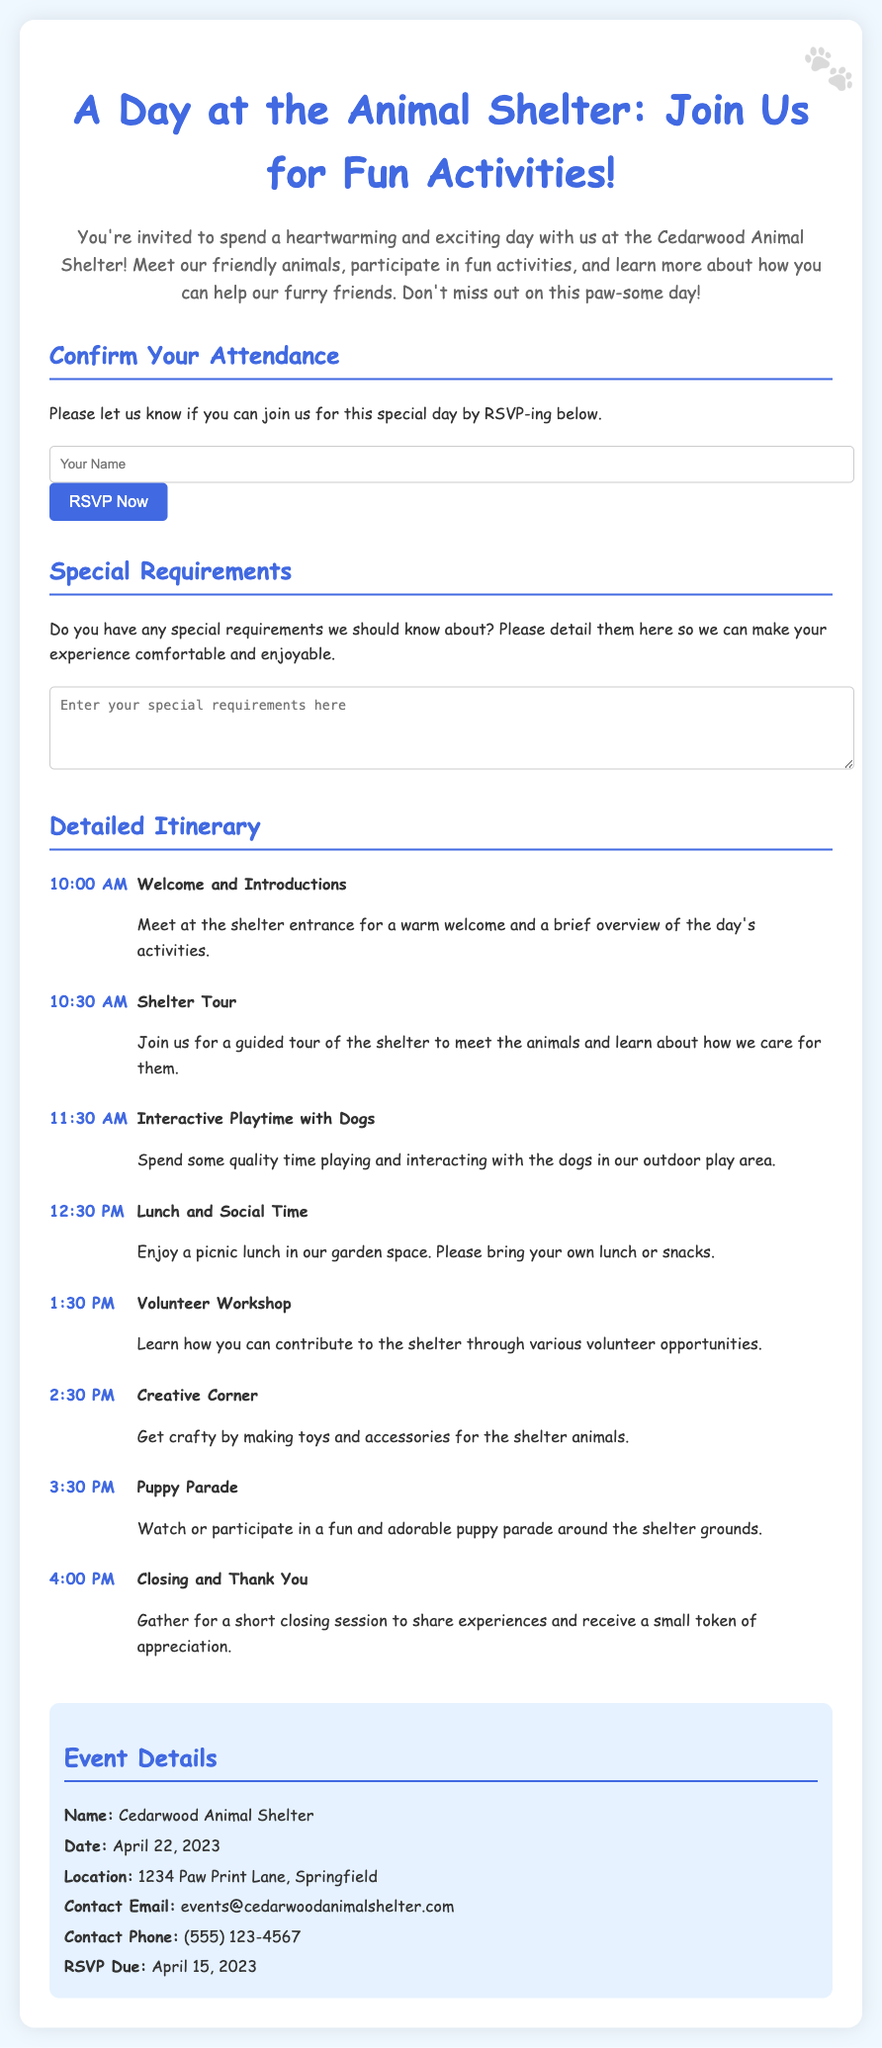What is the date of the event? The date of the event is mentioned in the document as April 22, 2023.
Answer: April 22, 2023 What activities are scheduled for 1:30 PM? The document lists the "Volunteer Workshop" as the activity scheduled for 1:30 PM.
Answer: Volunteer Workshop Where is the animal shelter located? The location of the shelter is specified in the document as 1234 Paw Print Lane, Springfield.
Answer: 1234 Paw Print Lane, Springfield What do attendees need to bring for lunch? The document indicates that attendees should bring their own lunch or snacks for the picnic lunch at 12:30 PM.
Answer: own lunch or snacks What is the RSVP due date? The RSVP due date is listed in the document as April 15, 2023.
Answer: April 15, 2023 Which activity involves making toys for the animals? The "Creative Corner" activity is described in the document as involving making toys and accessories for the shelter animals.
Answer: Creative Corner How can participants confirm their attendance? Participants can confirm their attendance by filling in their name in the RSVP section and clicking the "RSVP Now" button.
Answer: RSVP Now What is the contact email for the event? The document provides the contact email as events@cedarwoodanimalshelter.com.
Answer: events@cedarwoodanimalshelter.com What time does the "Puppy Parade" start? The "Puppy Parade" starts at 3:30 PM according to the schedule in the document.
Answer: 3:30 PM 